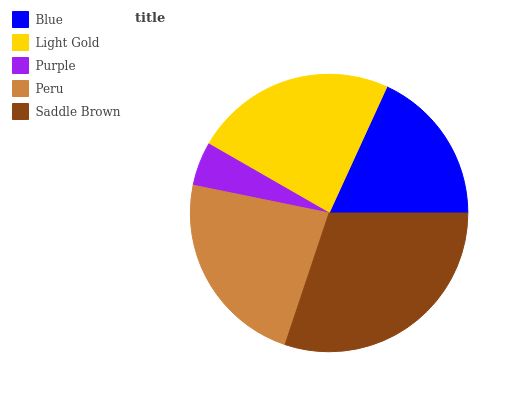Is Purple the minimum?
Answer yes or no. Yes. Is Saddle Brown the maximum?
Answer yes or no. Yes. Is Light Gold the minimum?
Answer yes or no. No. Is Light Gold the maximum?
Answer yes or no. No. Is Light Gold greater than Blue?
Answer yes or no. Yes. Is Blue less than Light Gold?
Answer yes or no. Yes. Is Blue greater than Light Gold?
Answer yes or no. No. Is Light Gold less than Blue?
Answer yes or no. No. Is Peru the high median?
Answer yes or no. Yes. Is Peru the low median?
Answer yes or no. Yes. Is Purple the high median?
Answer yes or no. No. Is Light Gold the low median?
Answer yes or no. No. 